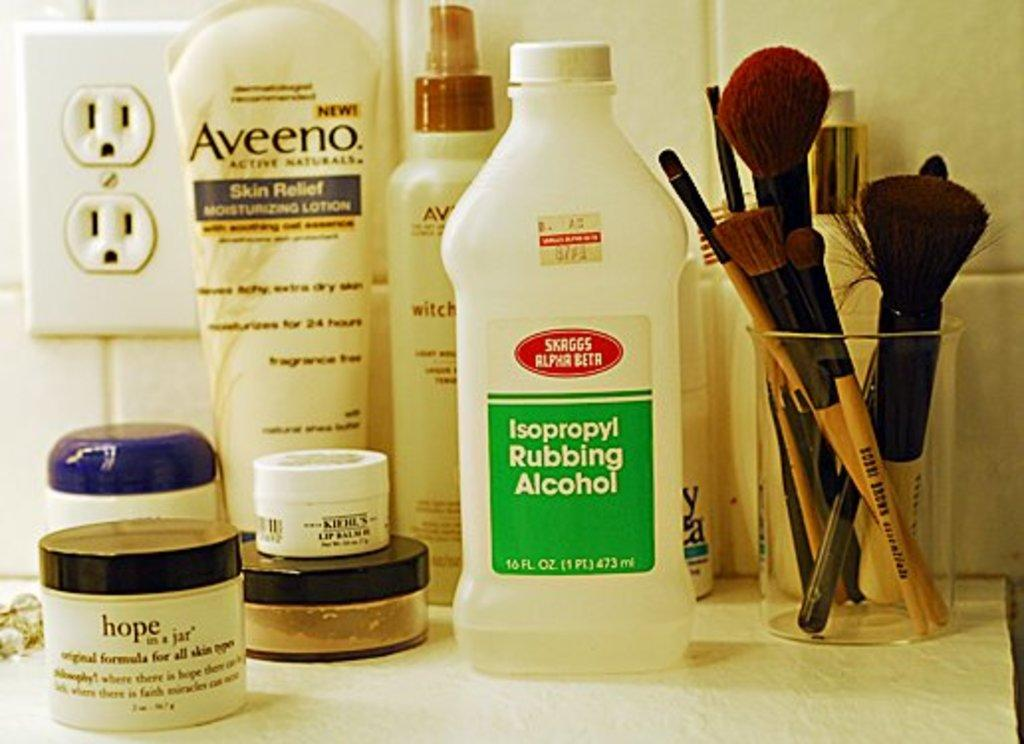<image>
Summarize the visual content of the image. Rubbing alcohol, Aveeno lotion make up brushes and other items sitting on a counter. 